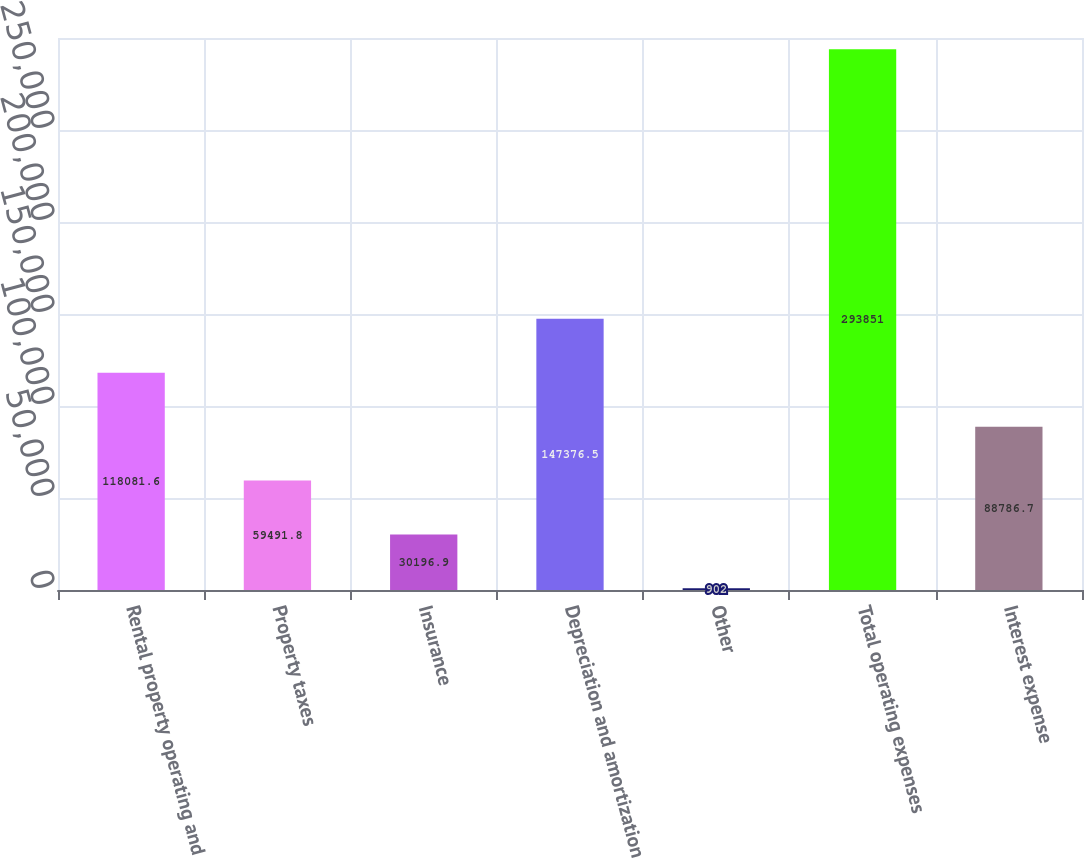Convert chart. <chart><loc_0><loc_0><loc_500><loc_500><bar_chart><fcel>Rental property operating and<fcel>Property taxes<fcel>Insurance<fcel>Depreciation and amortization<fcel>Other<fcel>Total operating expenses<fcel>Interest expense<nl><fcel>118082<fcel>59491.8<fcel>30196.9<fcel>147376<fcel>902<fcel>293851<fcel>88786.7<nl></chart> 